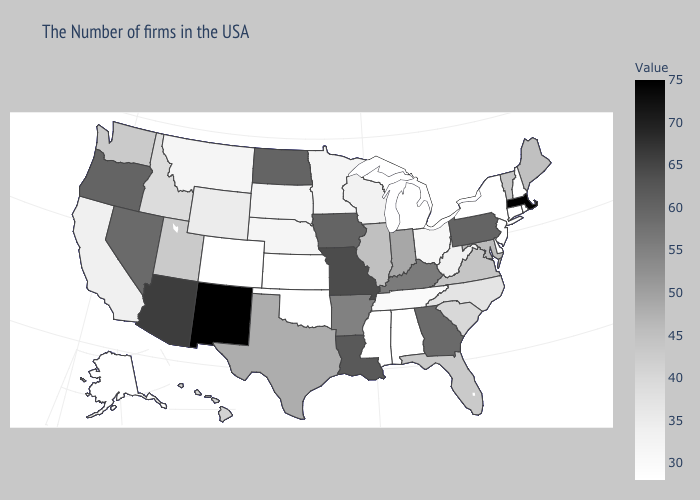Does Iowa have a lower value than Montana?
Give a very brief answer. No. Which states hav the highest value in the South?
Quick response, please. Louisiana. Among the states that border Massachusetts , does New York have the highest value?
Be succinct. No. Does Ohio have a lower value than Iowa?
Keep it brief. Yes. Does Wyoming have the lowest value in the West?
Give a very brief answer. No. Among the states that border Rhode Island , which have the highest value?
Give a very brief answer. Massachusetts. 